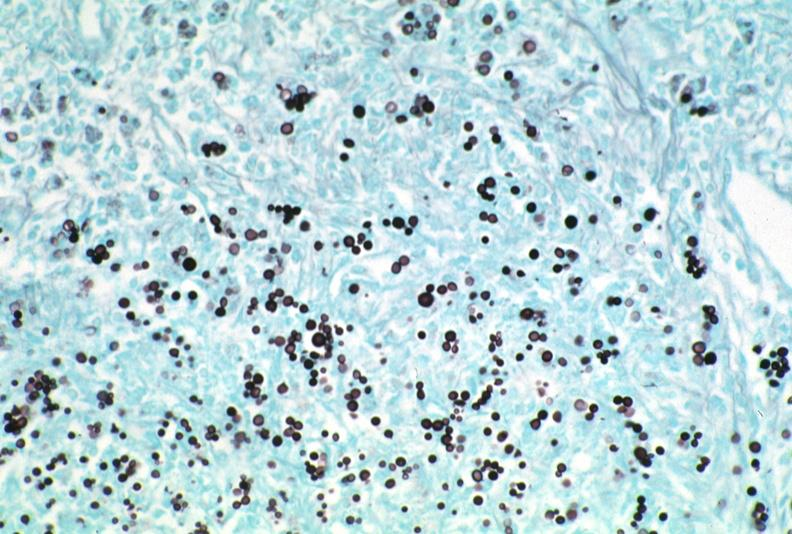what does this image show?
Answer the question using a single word or phrase. Lymph node 